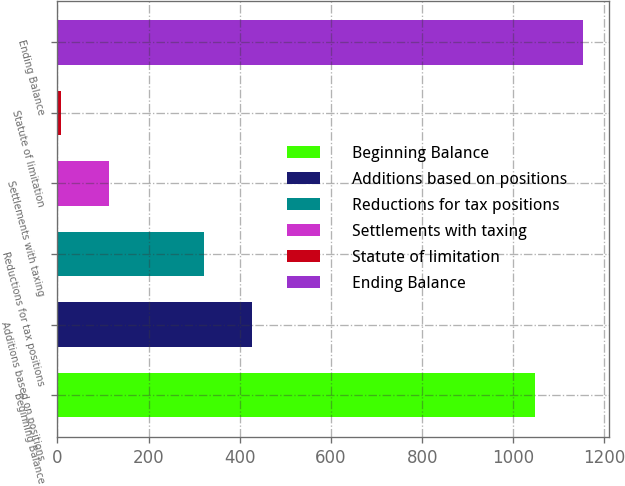Convert chart. <chart><loc_0><loc_0><loc_500><loc_500><bar_chart><fcel>Beginning Balance<fcel>Additions based on positions<fcel>Reductions for tax positions<fcel>Settlements with taxing<fcel>Statute of limitation<fcel>Ending Balance<nl><fcel>1047<fcel>426.6<fcel>321.7<fcel>111.9<fcel>7<fcel>1151.9<nl></chart> 